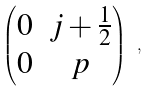Convert formula to latex. <formula><loc_0><loc_0><loc_500><loc_500>\begin{pmatrix} 0 & j + \frac { 1 } { 2 } \\ 0 & p \end{pmatrix} \ ,</formula> 